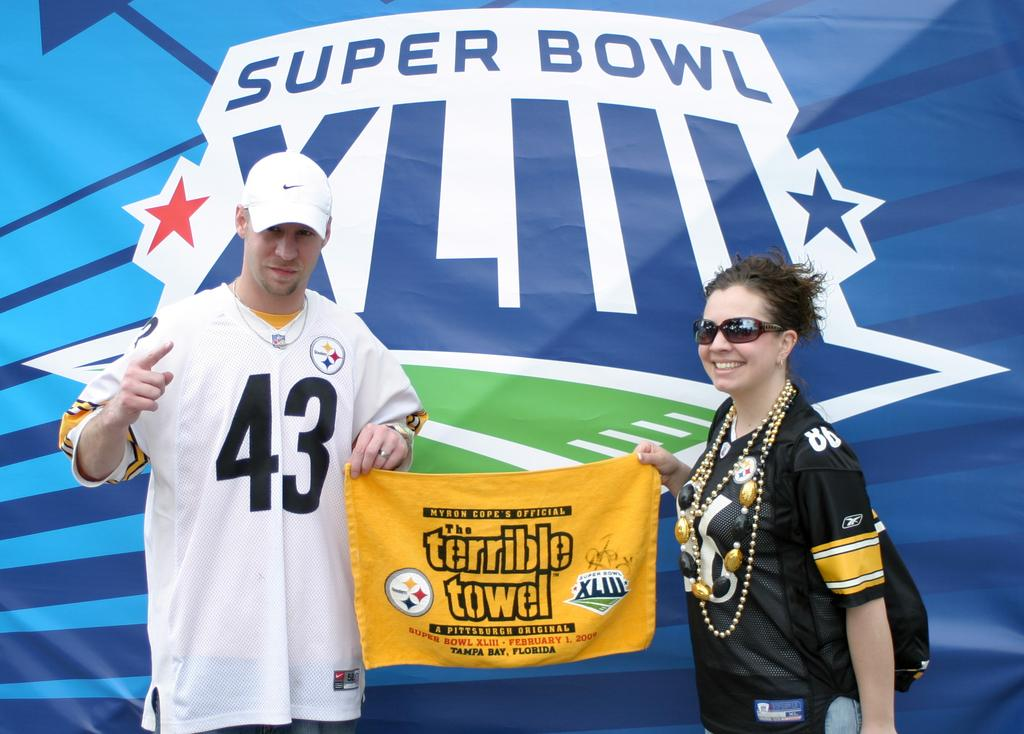<image>
Summarize the visual content of the image. two people hod a Terrible Towel under a Super Bowl sign 